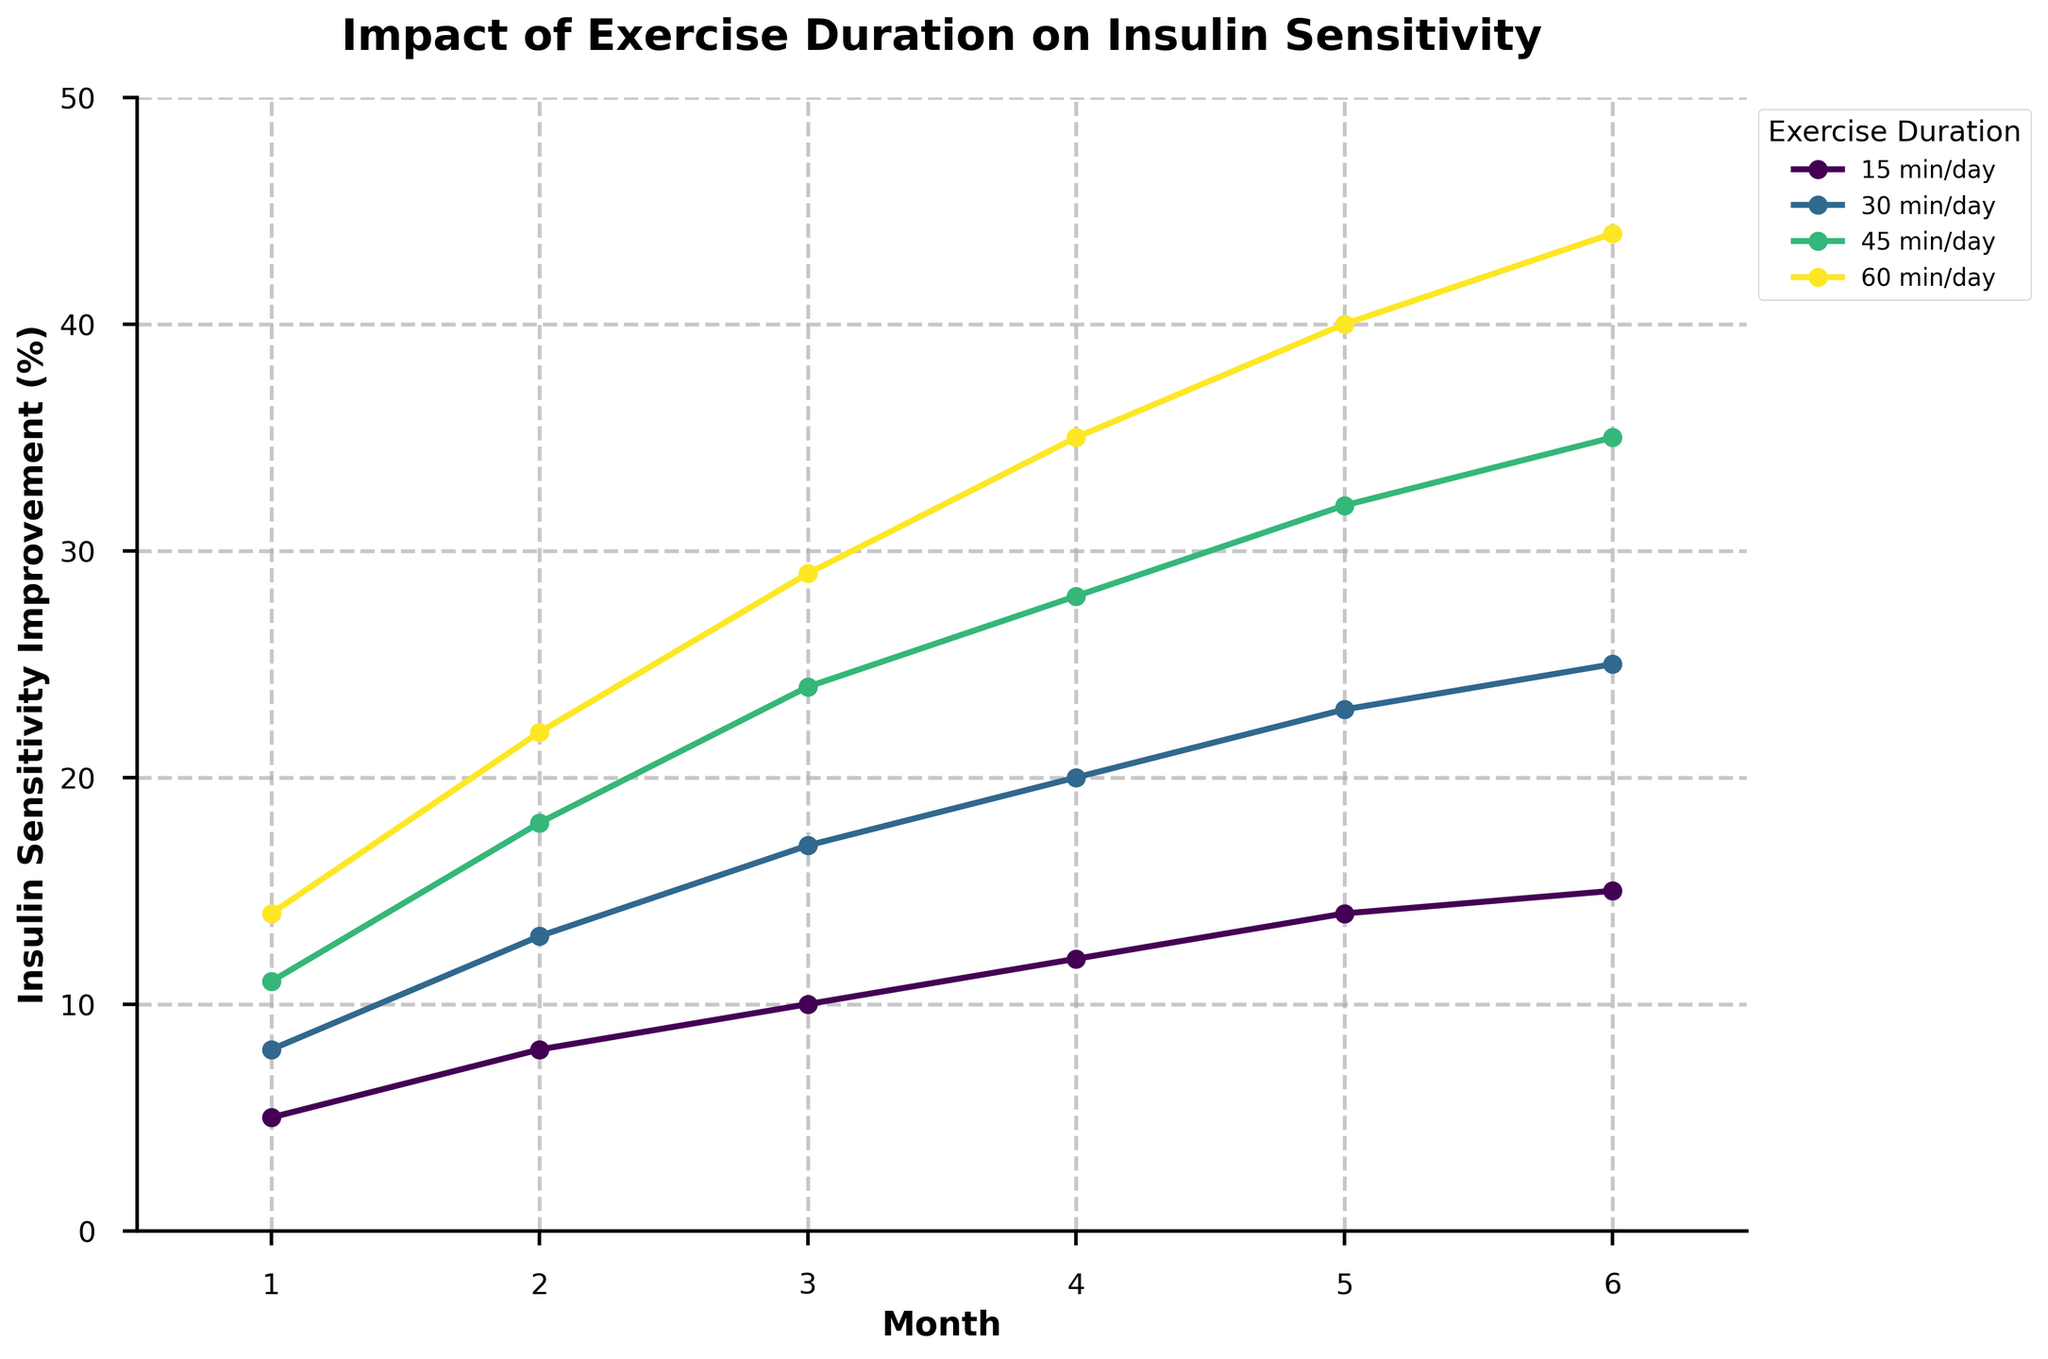What is the overall trend of insulin sensitivity improvement for someone exercising 45 minutes per day over the 6 months? The figure shows that for individuals exercising 45 minutes per day, the insulin sensitivity improvement increases steadily each month from 11% in month 1 to 35% in month 6. This indicates a consistently positive trend in insulin sensitivity improvement.
Answer: Steadily increases Which exercise duration shows the highest insulin sensitivity improvement in month 4? By examining the figure, the highest insulin sensitivity improvement in month 4 is shown by the 60 minutes per day exercise duration, which has an improvement of 35%.
Answer: 60 minutes per day Compare the insulin sensitivity improvements between 30 minutes and 60 minutes exercise durations in month 2. In month 2, the figure shows that the insulin sensitivity improvement for 30 minutes per day is 13%, while for 60 minutes per day it is 22%.
Answer: 22% for 60 minutes and 13% for 30 minutes How does the insulin sensitivity improvement for 15 minutes per day in month 6 compare to 60 minutes per day in the same month? The figure indicates an insulin sensitivity improvement of 15% for 15 minutes per day in month 6, compared to 44% for 60 minutes per day.
Answer: 15% for 15 minutes and 44% for 60 minutes What is the average improvement in insulin sensitivity for the 30 minutes exercise duration across the 6 months? Adding the improvements for 30 minutes per day over 6 months (8%, 13%, 17%, 20%, 23%, 25%) and dividing by 6 results in an average: (8 + 13 + 17 + 20 + 23 + 25) / 6 = 106 / 6 ≈ 17.67%.
Answer: 17.67% Which exercise duration shows the most significant change in insulin sensitivity improvement from month 1 to month 6? By comparing the improvements from month 1 to month 6 for all durations, the 60 minutes per day duration shows the most significant change, increasing from 14% to 44%, a difference of 30%.
Answer: 60 minutes per day For the 30 minutes per day exercise duration, how much did the insulin sensitivity improve from month 3 to month 5? The improvement in month 3 is 17% and in month 5 is 23%. The change from month 3 to month 5 is 23% - 17% = 6%.
Answer: 6% What is the visual representation of the trend for 15 minutes per day exercise duration? The line representing 15 minutes per day is displayed with markers and a consistent increase in insulin sensitivity improvement across the months, colored differently for visual differentiation.
Answer: Consistent upward slope with markers How many different exercise durations are compared in the chart? The chart has distinct lines representing different exercise durations, which are 15, 30, 45, and 60 minutes per day. Therefore, there are four distinct exercise durations.
Answer: 4 